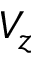<formula> <loc_0><loc_0><loc_500><loc_500>V _ { z }</formula> 